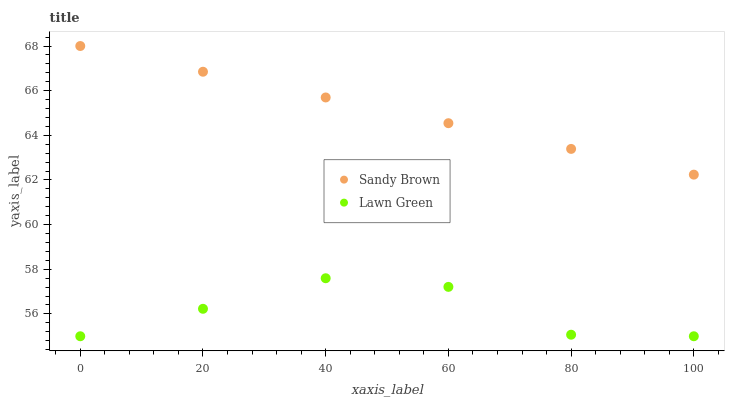Does Lawn Green have the minimum area under the curve?
Answer yes or no. Yes. Does Sandy Brown have the maximum area under the curve?
Answer yes or no. Yes. Does Sandy Brown have the minimum area under the curve?
Answer yes or no. No. Is Sandy Brown the smoothest?
Answer yes or no. Yes. Is Lawn Green the roughest?
Answer yes or no. Yes. Is Sandy Brown the roughest?
Answer yes or no. No. Does Lawn Green have the lowest value?
Answer yes or no. Yes. Does Sandy Brown have the lowest value?
Answer yes or no. No. Does Sandy Brown have the highest value?
Answer yes or no. Yes. Is Lawn Green less than Sandy Brown?
Answer yes or no. Yes. Is Sandy Brown greater than Lawn Green?
Answer yes or no. Yes. Does Lawn Green intersect Sandy Brown?
Answer yes or no. No. 